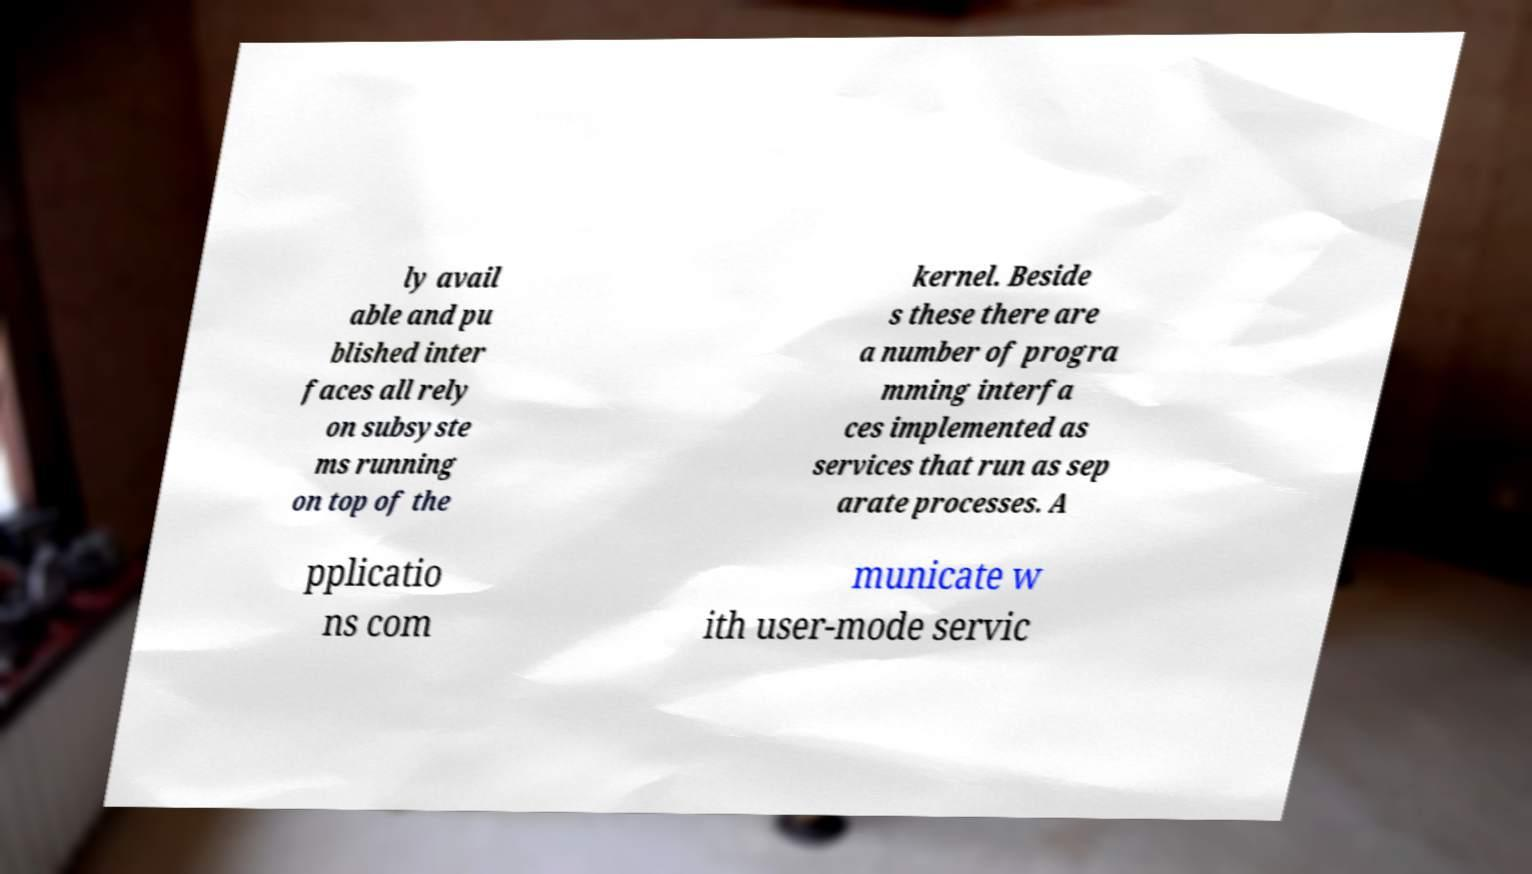Could you assist in decoding the text presented in this image and type it out clearly? ly avail able and pu blished inter faces all rely on subsyste ms running on top of the kernel. Beside s these there are a number of progra mming interfa ces implemented as services that run as sep arate processes. A pplicatio ns com municate w ith user-mode servic 